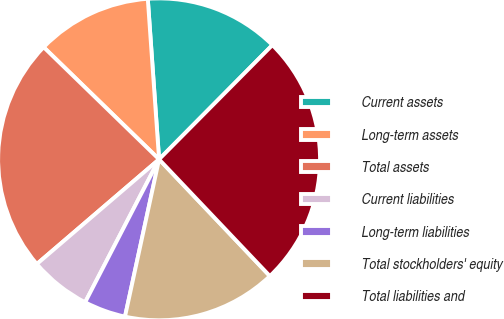Convert chart. <chart><loc_0><loc_0><loc_500><loc_500><pie_chart><fcel>Current assets<fcel>Long-term assets<fcel>Total assets<fcel>Current liabilities<fcel>Long-term liabilities<fcel>Total stockholders' equity<fcel>Total liabilities and<nl><fcel>13.55%<fcel>11.61%<fcel>23.54%<fcel>6.13%<fcel>4.2%<fcel>15.48%<fcel>25.48%<nl></chart> 